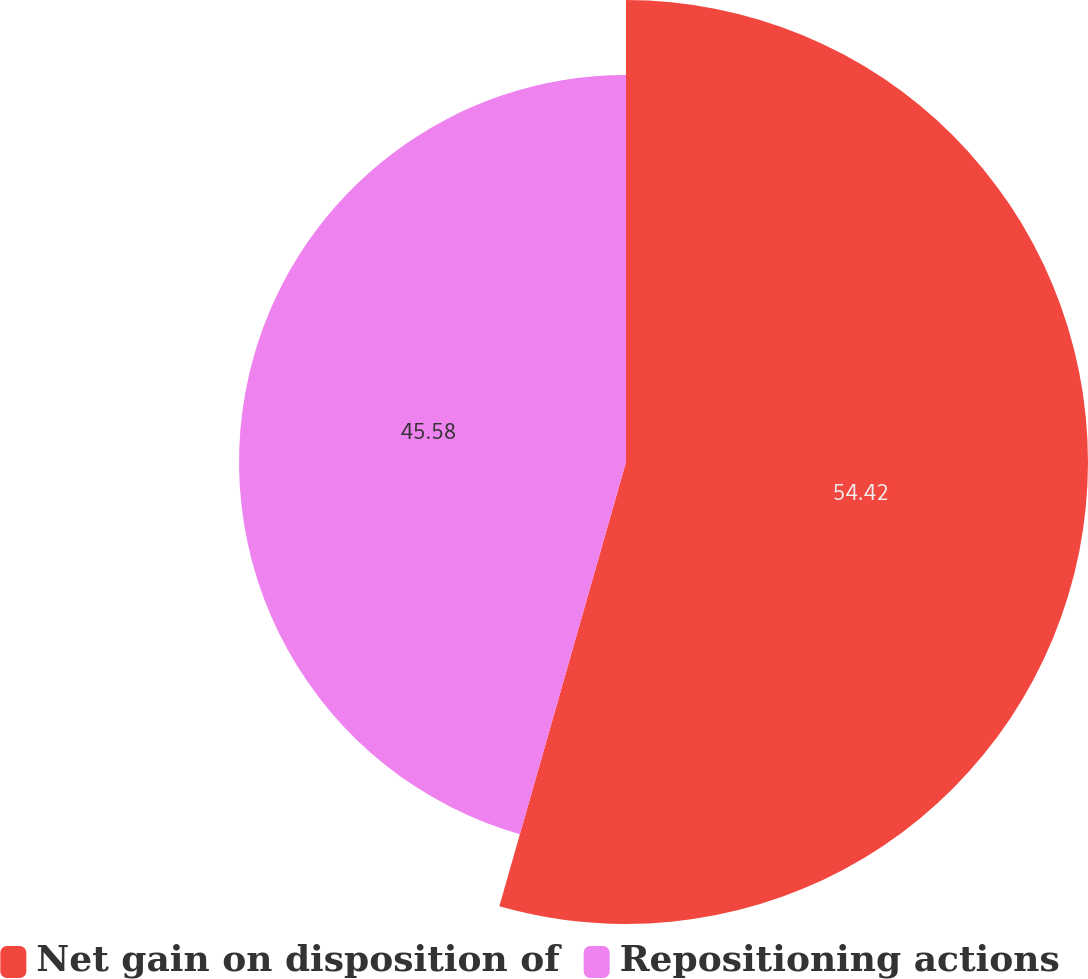Convert chart. <chart><loc_0><loc_0><loc_500><loc_500><pie_chart><fcel>Net gain on disposition of<fcel>Repositioning actions<nl><fcel>54.42%<fcel>45.58%<nl></chart> 